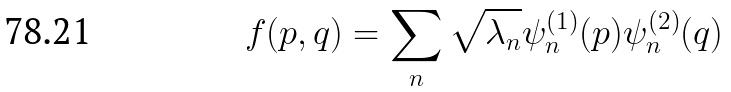Convert formula to latex. <formula><loc_0><loc_0><loc_500><loc_500>f ( p , q ) = \sum _ { n } \sqrt { \lambda _ { n } } \psi ^ { ( 1 ) } _ { n } ( p ) \psi ^ { ( 2 ) } _ { n } ( q )</formula> 